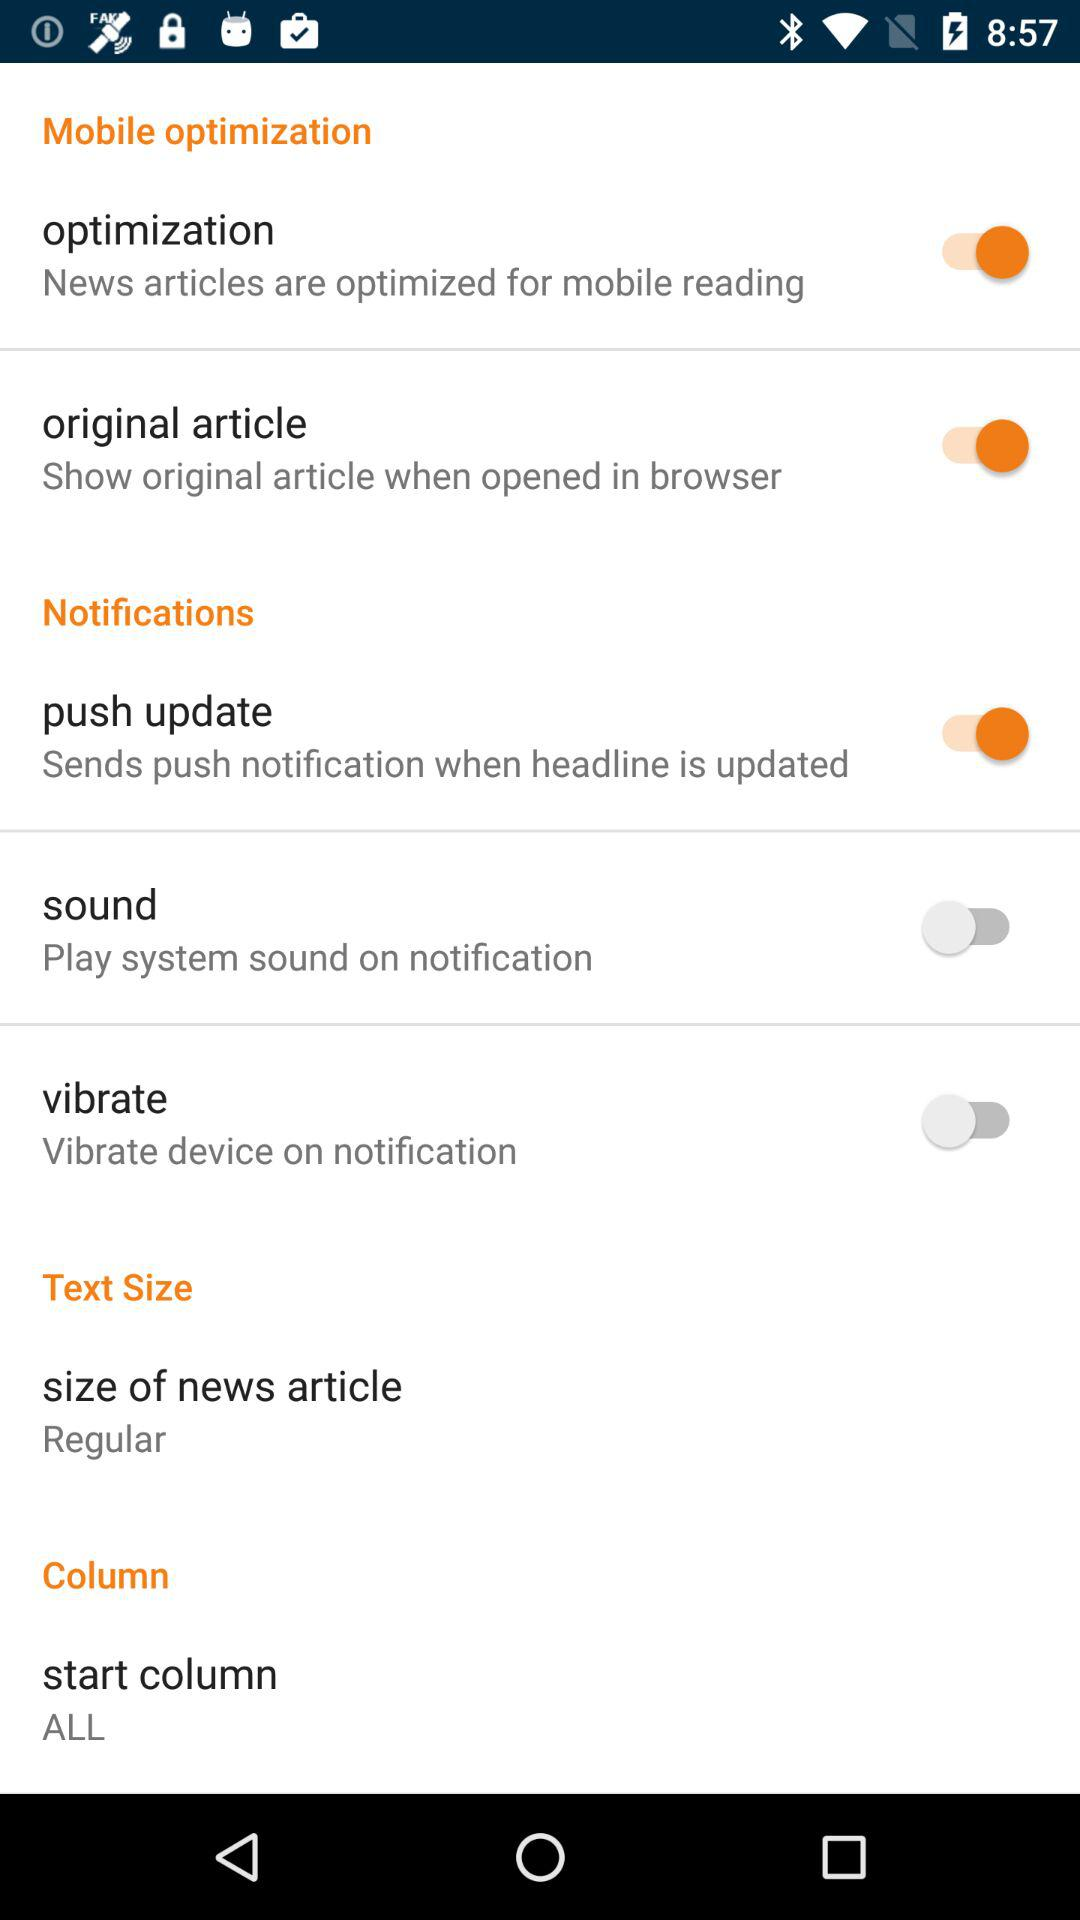What is the status of "push update"? The status of "push update" is "on". 